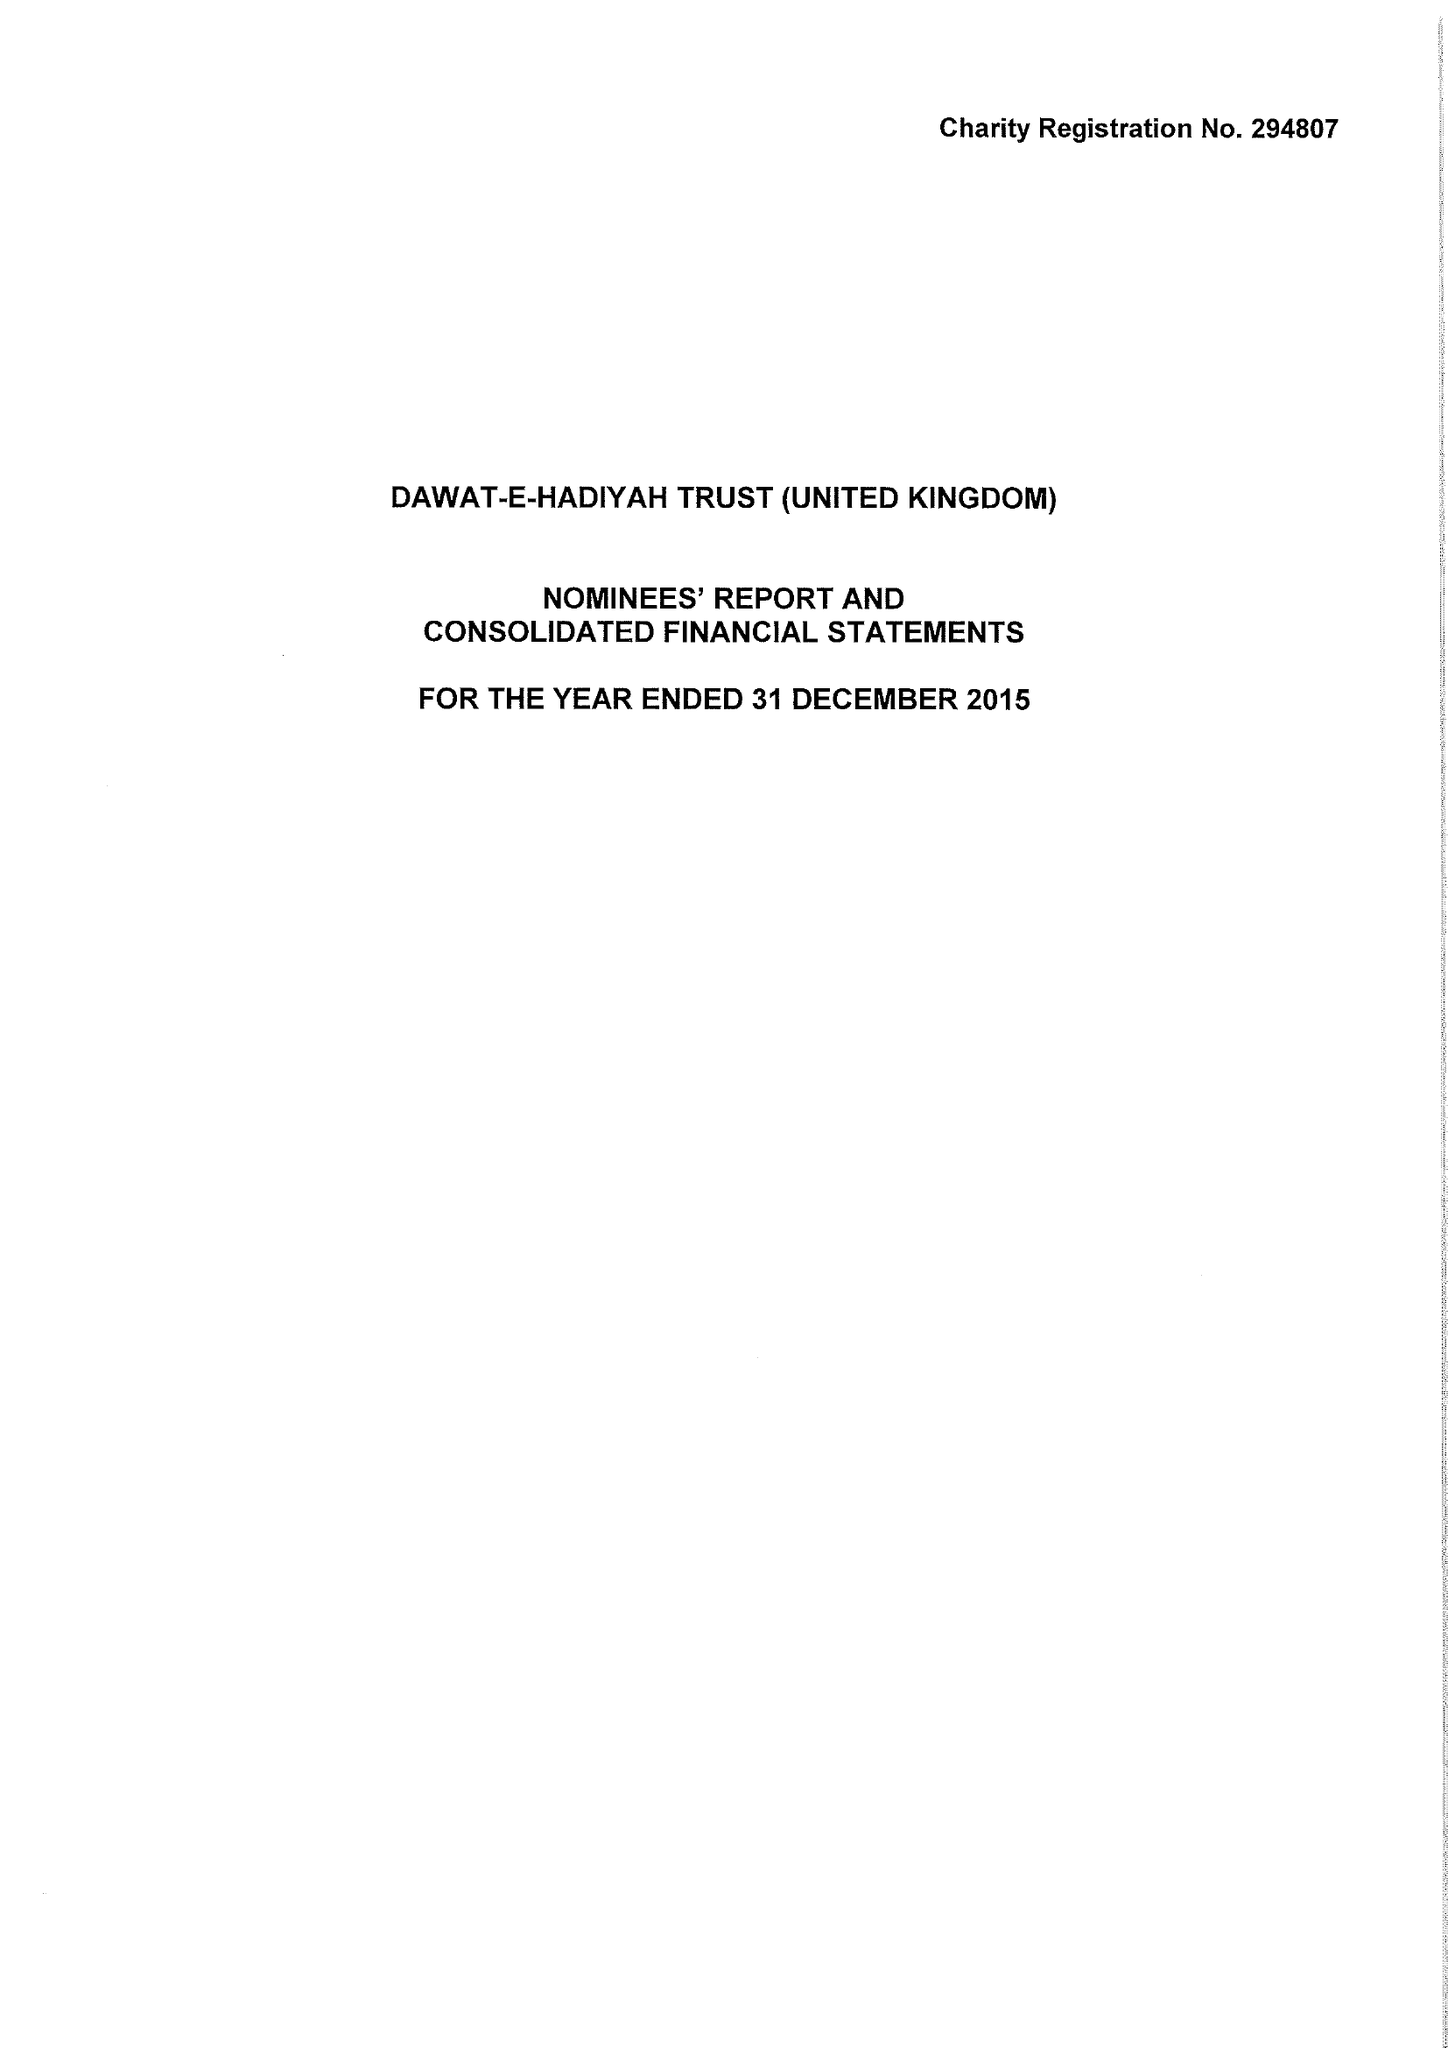What is the value for the address__postcode?
Answer the question using a single word or phrase. UB5 6AG 